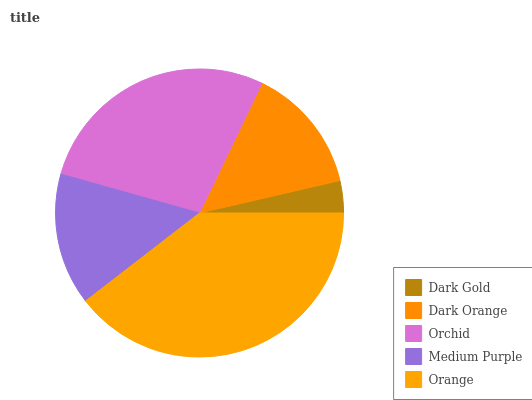Is Dark Gold the minimum?
Answer yes or no. Yes. Is Orange the maximum?
Answer yes or no. Yes. Is Dark Orange the minimum?
Answer yes or no. No. Is Dark Orange the maximum?
Answer yes or no. No. Is Dark Orange greater than Dark Gold?
Answer yes or no. Yes. Is Dark Gold less than Dark Orange?
Answer yes or no. Yes. Is Dark Gold greater than Dark Orange?
Answer yes or no. No. Is Dark Orange less than Dark Gold?
Answer yes or no. No. Is Medium Purple the high median?
Answer yes or no. Yes. Is Medium Purple the low median?
Answer yes or no. Yes. Is Dark Gold the high median?
Answer yes or no. No. Is Dark Orange the low median?
Answer yes or no. No. 